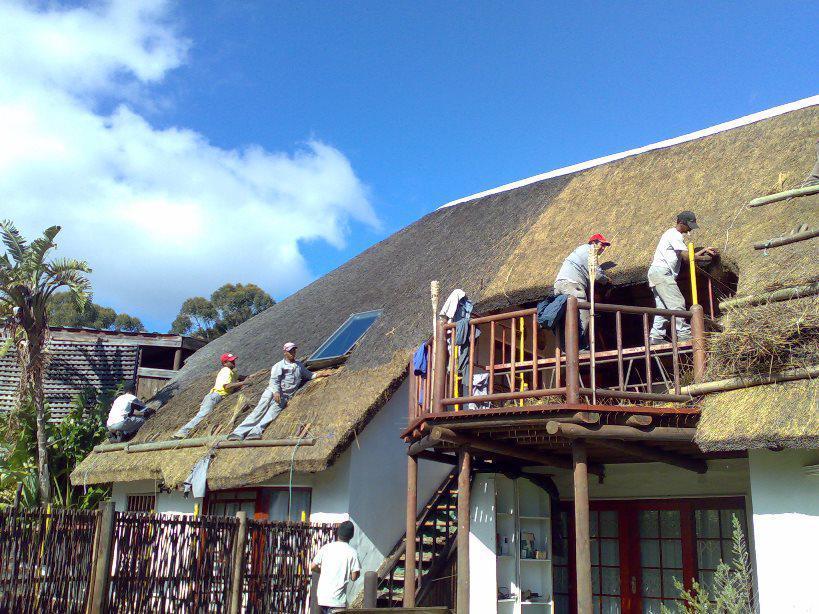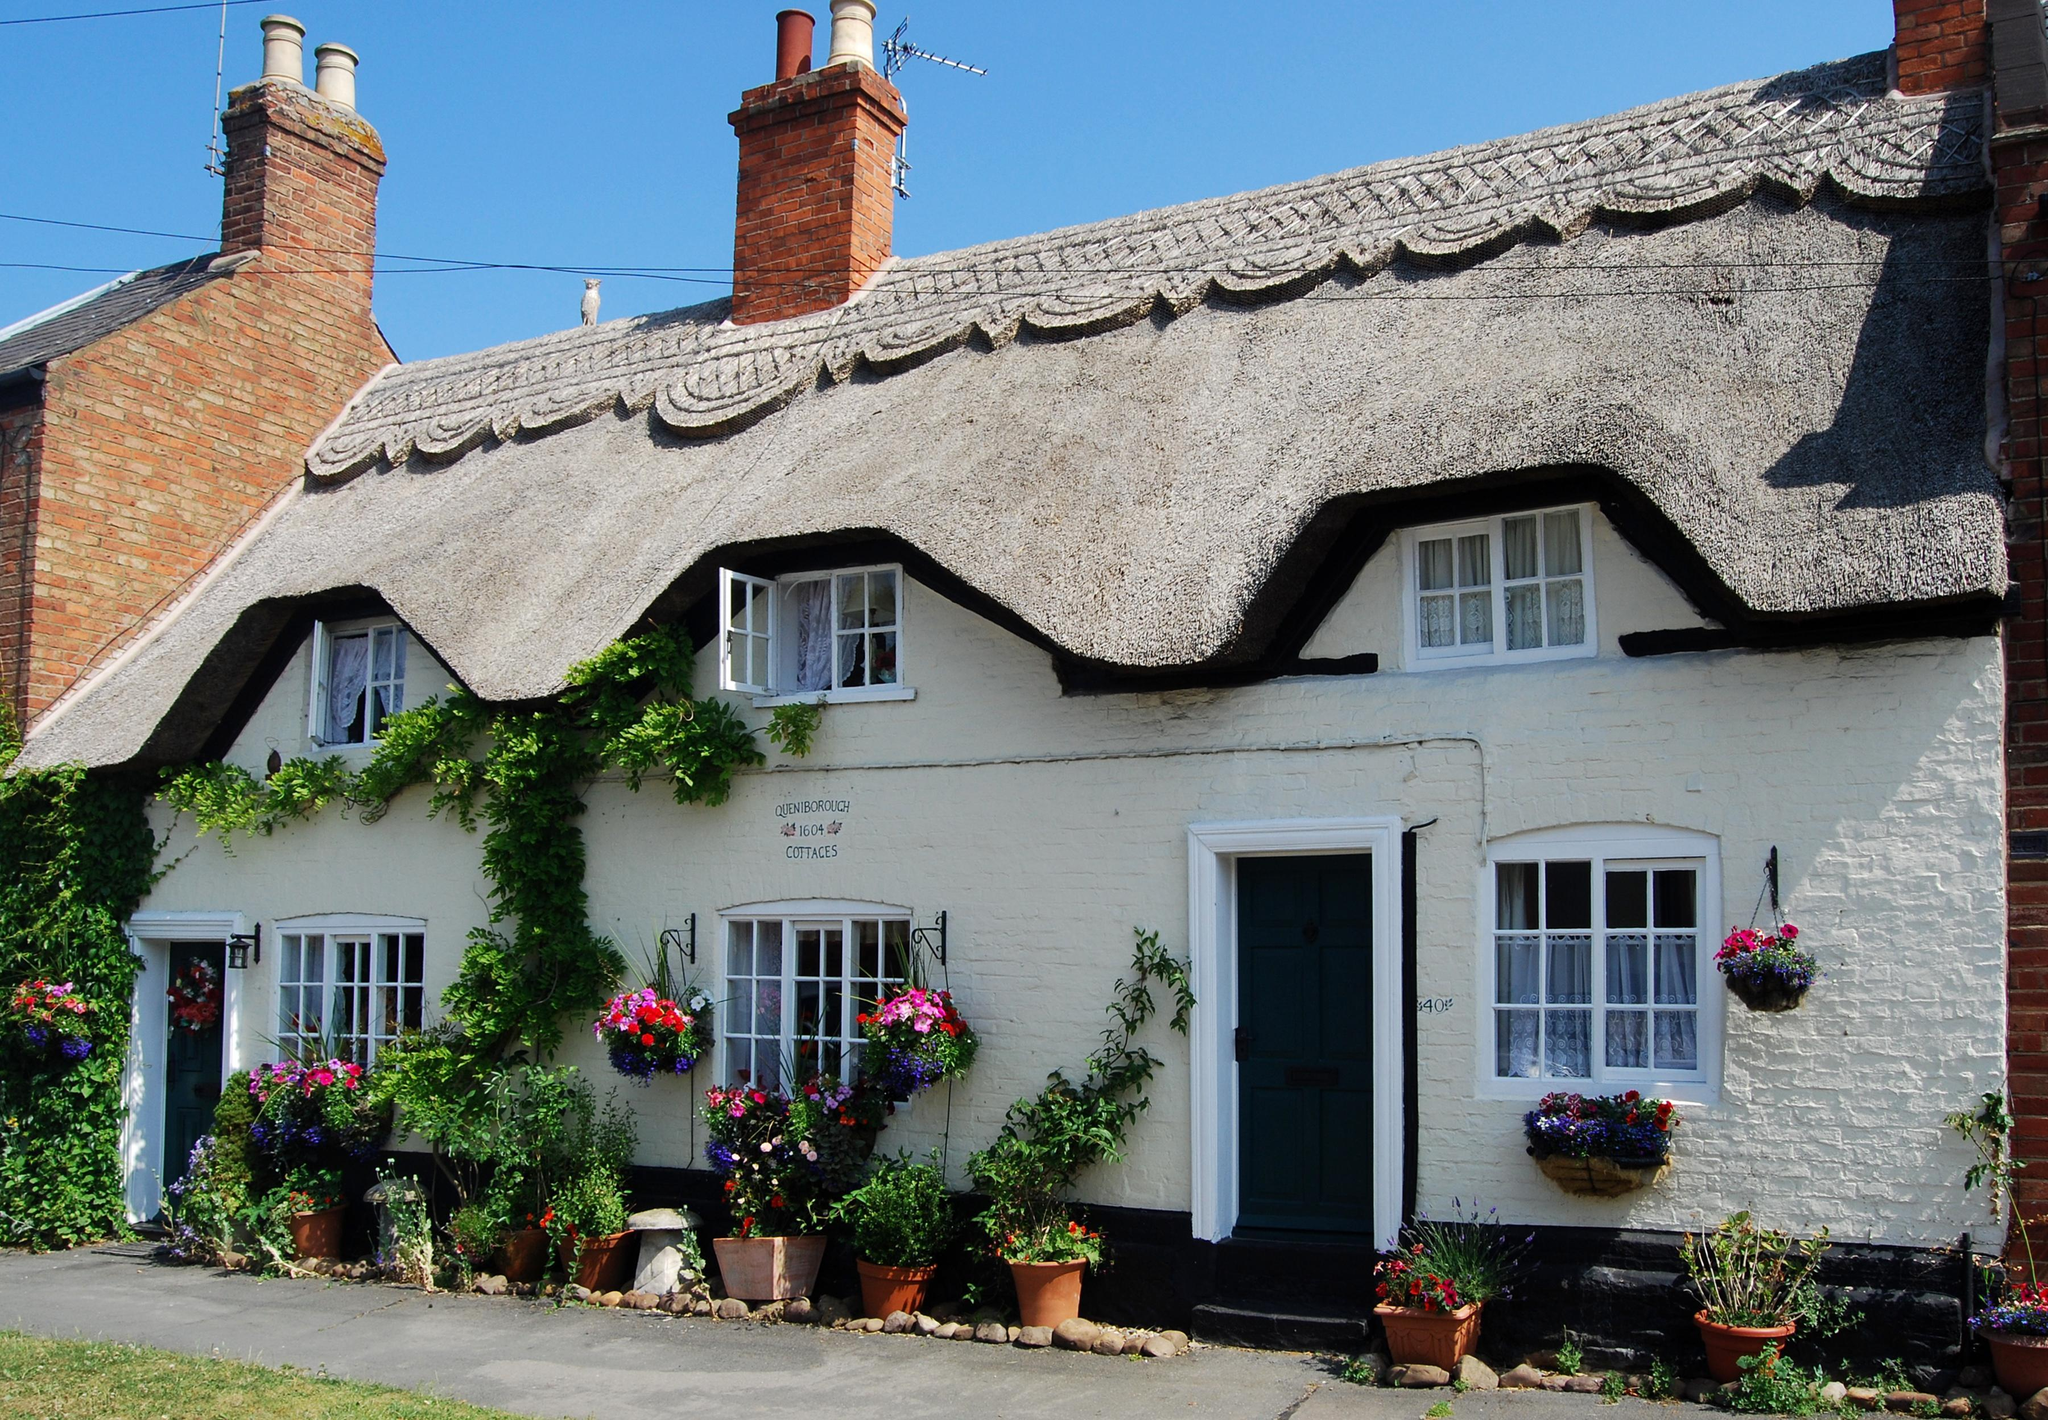The first image is the image on the left, the second image is the image on the right. Examine the images to the left and right. Is the description "The right image shows exactly one man on some type of platform in front of a sloped unfinished roof with at least one bundle of thatch propped on it and no chimney." accurate? Answer yes or no. No. The first image is the image on the left, the second image is the image on the right. Evaluate the accuracy of this statement regarding the images: "A single man is working on the roof of the house in the image on the right.". Is it true? Answer yes or no. No. 